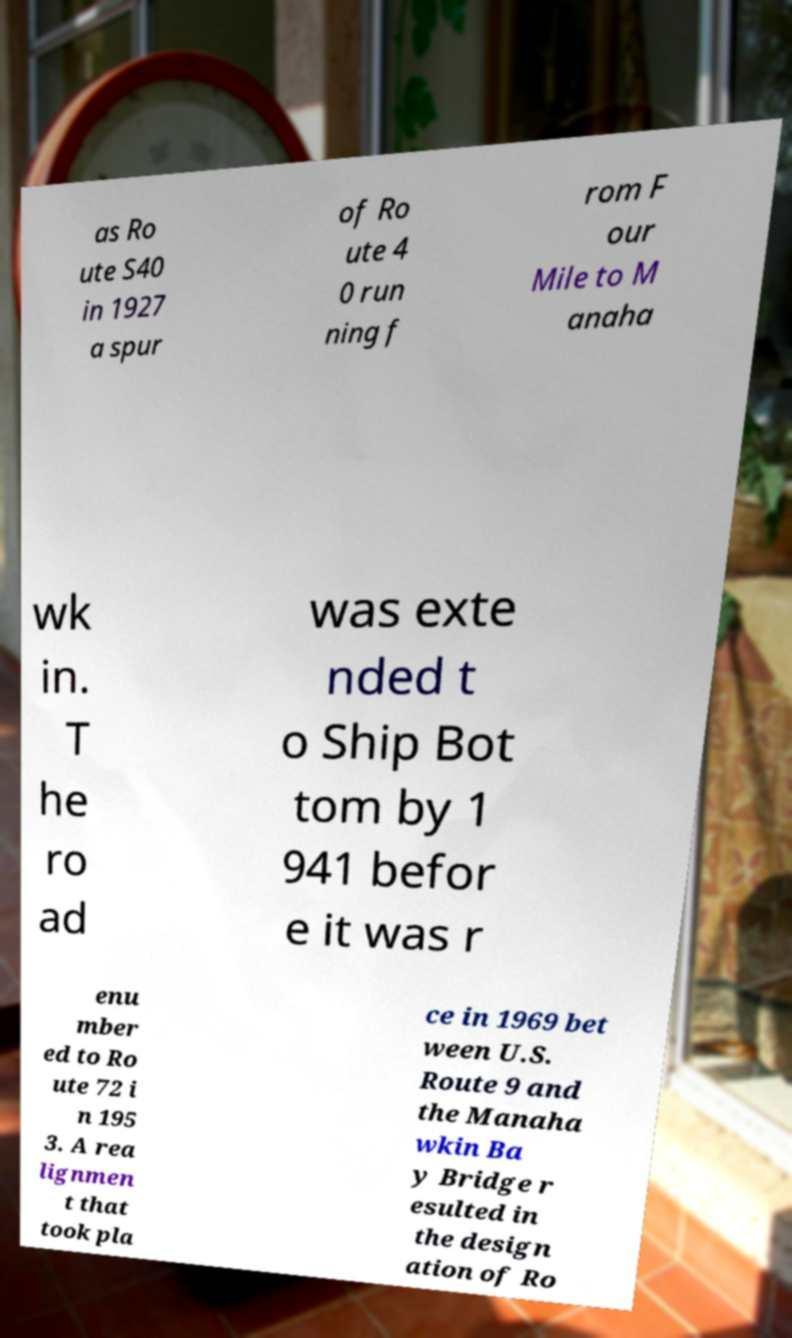There's text embedded in this image that I need extracted. Can you transcribe it verbatim? as Ro ute S40 in 1927 a spur of Ro ute 4 0 run ning f rom F our Mile to M anaha wk in. T he ro ad was exte nded t o Ship Bot tom by 1 941 befor e it was r enu mber ed to Ro ute 72 i n 195 3. A rea lignmen t that took pla ce in 1969 bet ween U.S. Route 9 and the Manaha wkin Ba y Bridge r esulted in the design ation of Ro 